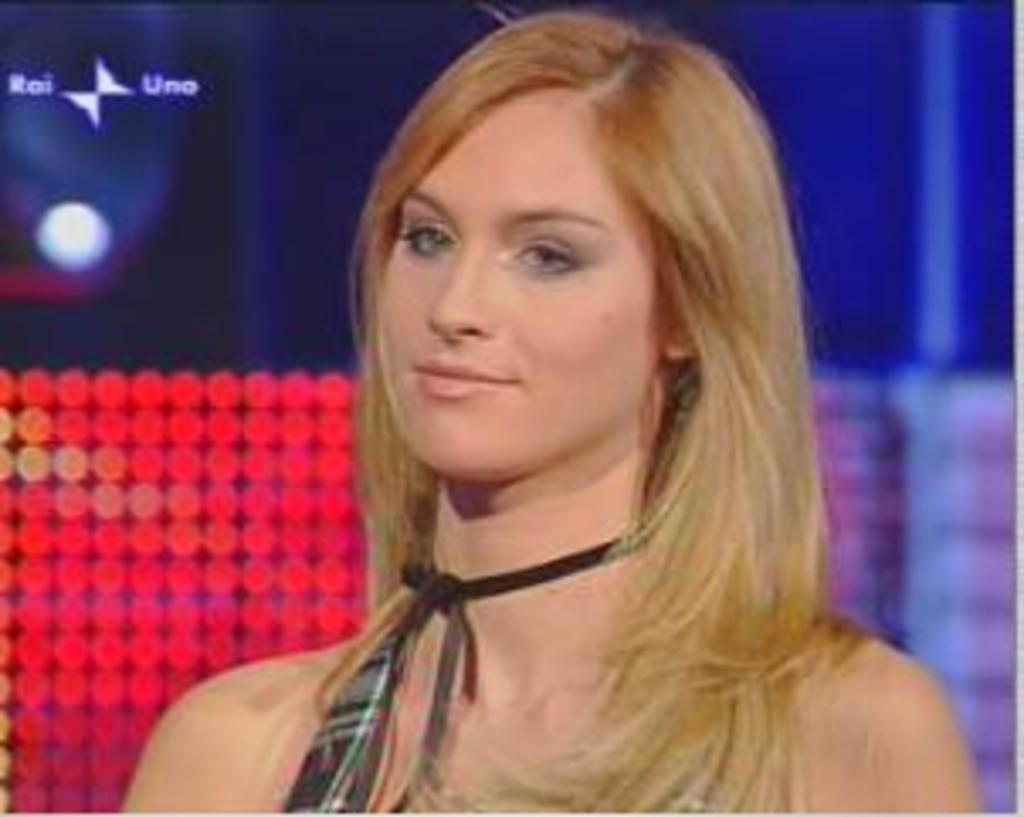Who is present in the image? There is a lady in the image. What can be seen in the background of the image? There are lights visible in the background of the image. What type of vessel is being used by the lady in the image during the summer? There is no vessel or reference to summer in the image; it only features a lady and lights in the background. 